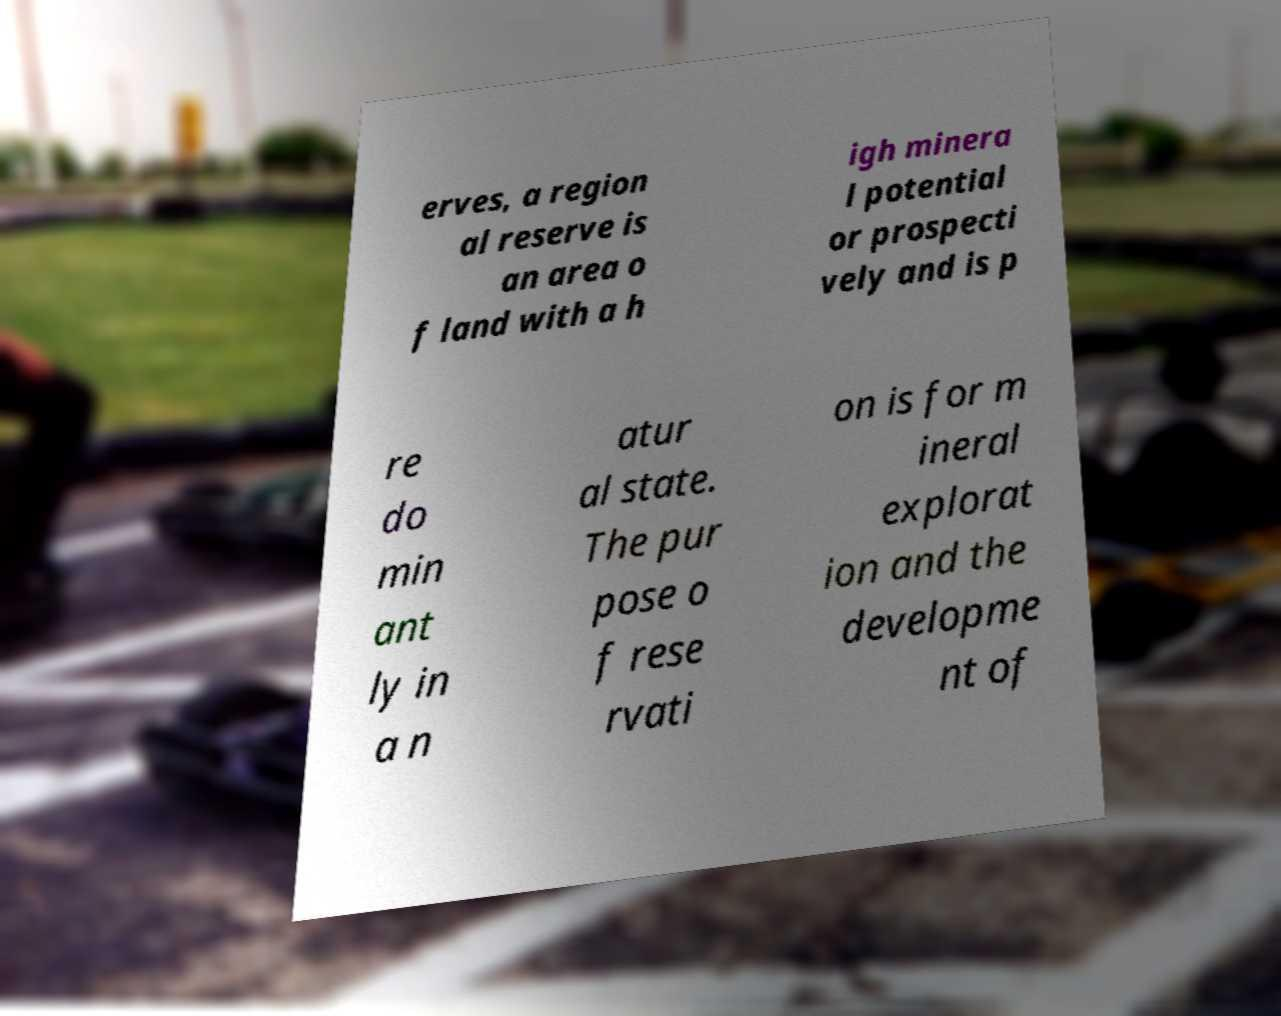Could you extract and type out the text from this image? erves, a region al reserve is an area o f land with a h igh minera l potential or prospecti vely and is p re do min ant ly in a n atur al state. The pur pose o f rese rvati on is for m ineral explorat ion and the developme nt of 